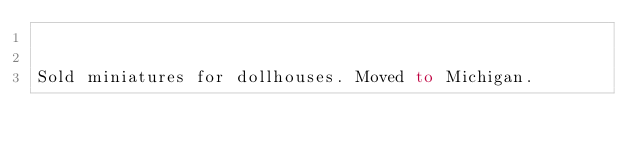Convert code to text. <code><loc_0><loc_0><loc_500><loc_500><_FORTRAN_>

Sold miniatures for dollhouses. Moved to Michigan.

</code> 